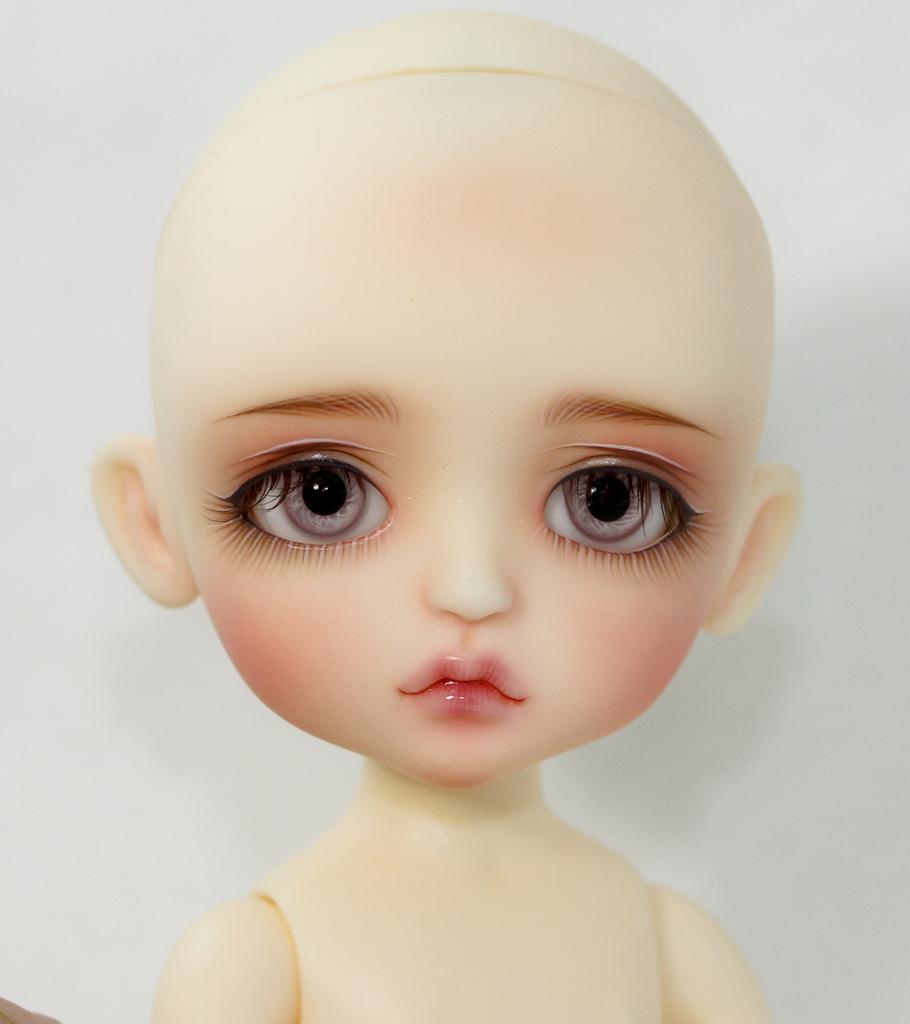In one or two sentences, can you explain what this image depicts? In this picture we can see a toy with a white background. 